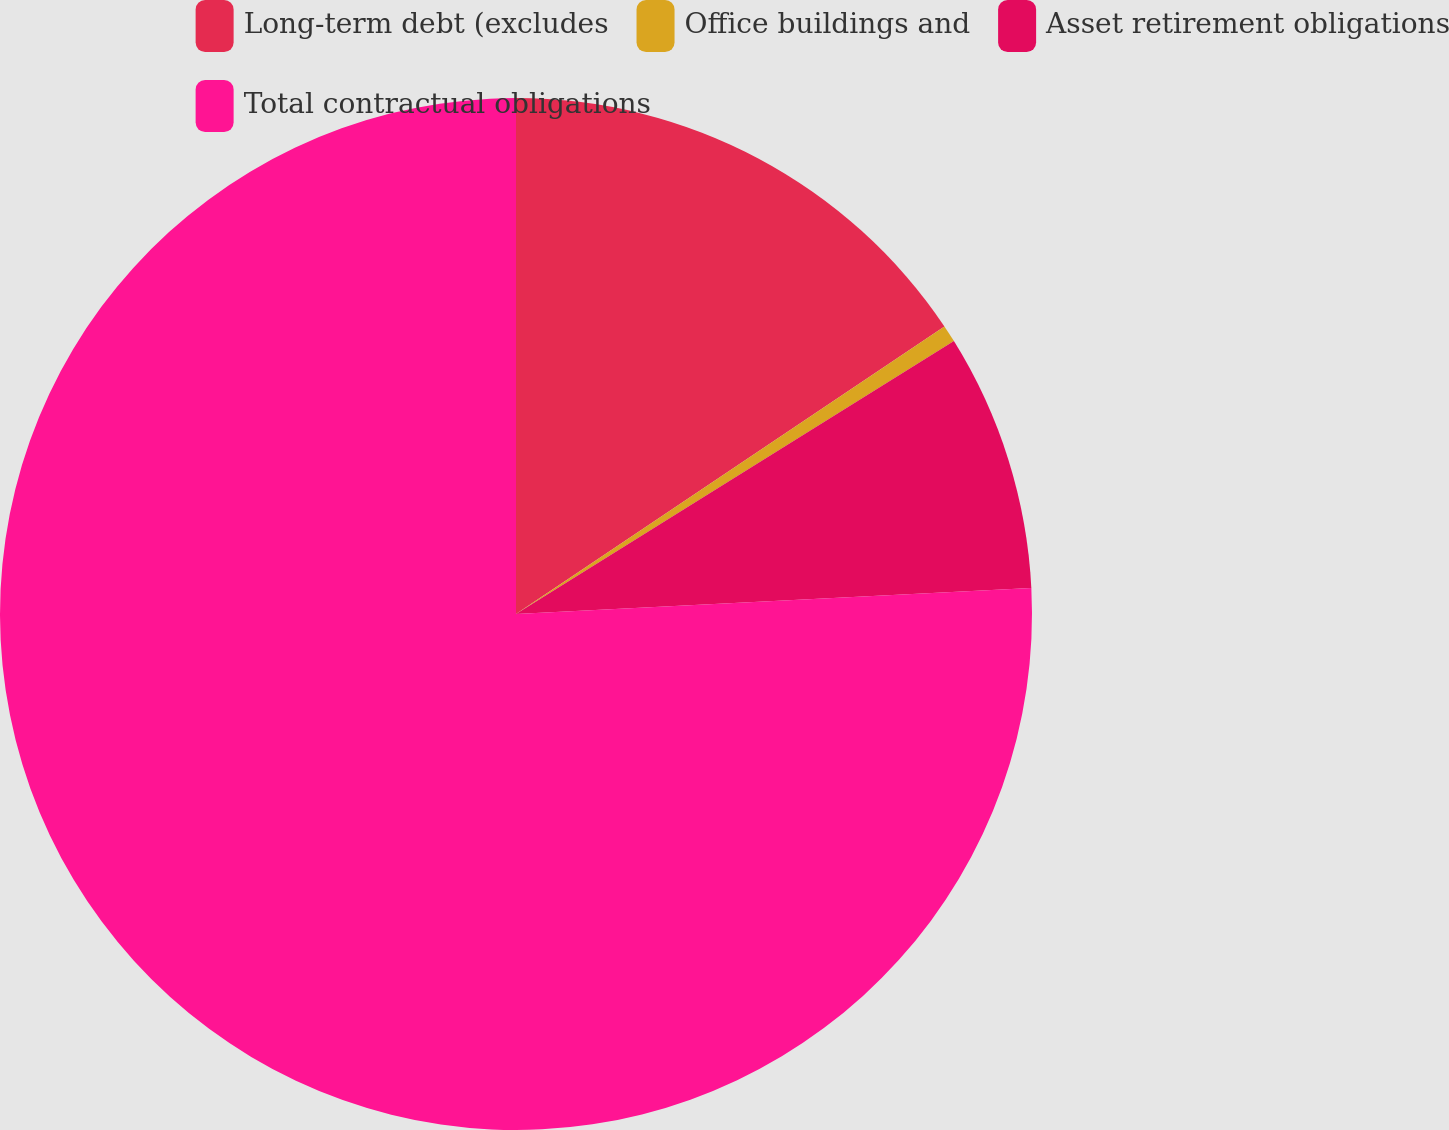Convert chart. <chart><loc_0><loc_0><loc_500><loc_500><pie_chart><fcel>Long-term debt (excludes<fcel>Office buildings and<fcel>Asset retirement obligations<fcel>Total contractual obligations<nl><fcel>15.59%<fcel>0.54%<fcel>8.07%<fcel>75.8%<nl></chart> 